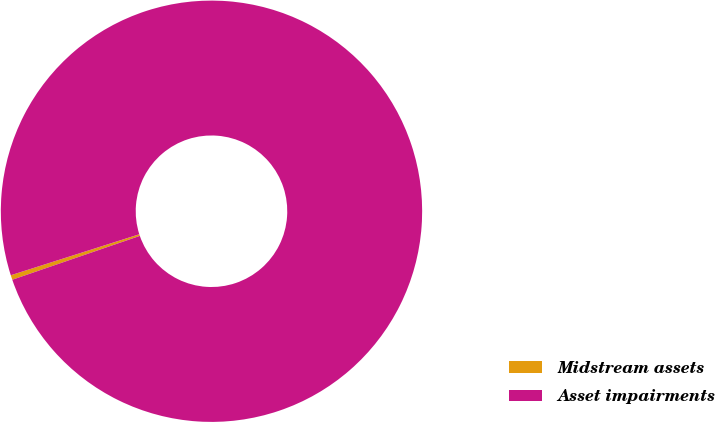Convert chart. <chart><loc_0><loc_0><loc_500><loc_500><pie_chart><fcel>Midstream assets<fcel>Asset impairments<nl><fcel>0.36%<fcel>99.64%<nl></chart> 